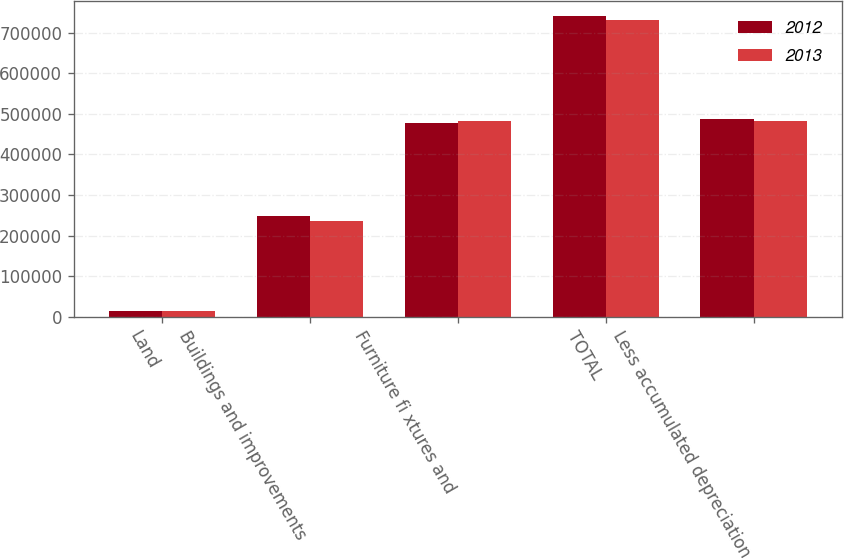Convert chart. <chart><loc_0><loc_0><loc_500><loc_500><stacked_bar_chart><ecel><fcel>Land<fcel>Buildings and improvements<fcel>Furniture fi xtures and<fcel>TOTAL<fcel>Less accumulated depreciation<nl><fcel>2012<fcel>14359<fcel>249034<fcel>477617<fcel>741010<fcel>487380<nl><fcel>2013<fcel>14359<fcel>236444<fcel>481382<fcel>732185<fcel>481389<nl></chart> 